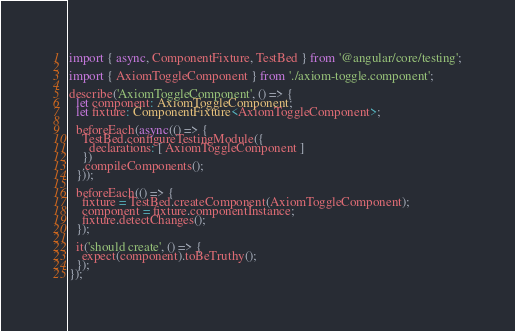Convert code to text. <code><loc_0><loc_0><loc_500><loc_500><_TypeScript_>import { async, ComponentFixture, TestBed } from '@angular/core/testing';

import { AxiomToggleComponent } from './axiom-toggle.component';

describe('AxiomToggleComponent', () => {
  let component: AxiomToggleComponent;
  let fixture: ComponentFixture<AxiomToggleComponent>;

  beforeEach(async(() => {
    TestBed.configureTestingModule({
      declarations: [ AxiomToggleComponent ]
    })
    .compileComponents();
  }));

  beforeEach(() => {
    fixture = TestBed.createComponent(AxiomToggleComponent);
    component = fixture.componentInstance;
    fixture.detectChanges();
  });

  it('should create', () => {
    expect(component).toBeTruthy();
  });
});
</code> 